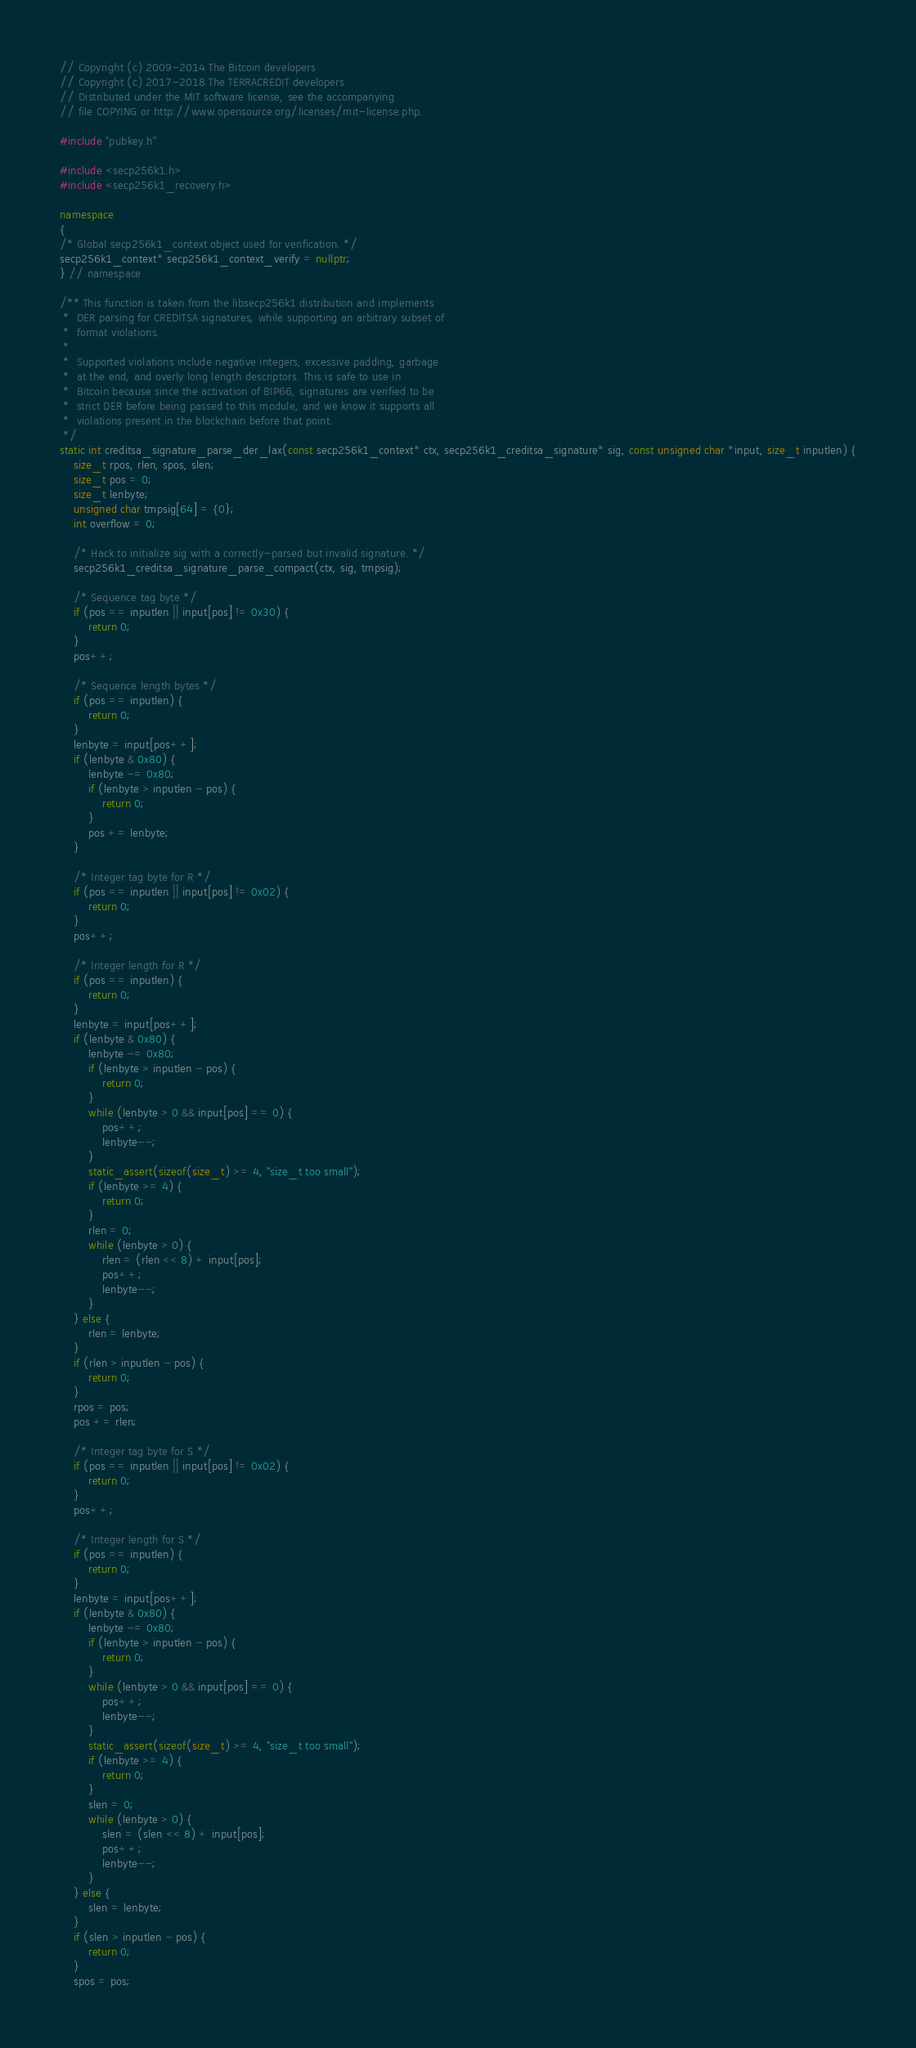<code> <loc_0><loc_0><loc_500><loc_500><_C++_>// Copyright (c) 2009-2014 The Bitcoin developers
// Copyright (c) 2017-2018 The TERRACREDIT developers
// Distributed under the MIT software license, see the accompanying
// file COPYING or http://www.opensource.org/licenses/mit-license.php.

#include "pubkey.h"

#include <secp256k1.h>
#include <secp256k1_recovery.h>

namespace
{
/* Global secp256k1_context object used for verification. */
secp256k1_context* secp256k1_context_verify = nullptr;
} // namespace

/** This function is taken from the libsecp256k1 distribution and implements
 *  DER parsing for CREDITSA signatures, while supporting an arbitrary subset of
 *  format violations.
 *
 *  Supported violations include negative integers, excessive padding, garbage
 *  at the end, and overly long length descriptors. This is safe to use in
 *  Bitcoin because since the activation of BIP66, signatures are verified to be
 *  strict DER before being passed to this module, and we know it supports all
 *  violations present in the blockchain before that point.
 */
static int creditsa_signature_parse_der_lax(const secp256k1_context* ctx, secp256k1_creditsa_signature* sig, const unsigned char *input, size_t inputlen) {
    size_t rpos, rlen, spos, slen;
    size_t pos = 0;
    size_t lenbyte;
    unsigned char tmpsig[64] = {0};
    int overflow = 0;

    /* Hack to initialize sig with a correctly-parsed but invalid signature. */
    secp256k1_creditsa_signature_parse_compact(ctx, sig, tmpsig);

    /* Sequence tag byte */
    if (pos == inputlen || input[pos] != 0x30) {
        return 0;
    }
    pos++;

    /* Sequence length bytes */
    if (pos == inputlen) {
        return 0;
    }
    lenbyte = input[pos++];
    if (lenbyte & 0x80) {
        lenbyte -= 0x80;
        if (lenbyte > inputlen - pos) {
            return 0;
        }
        pos += lenbyte;
    }

    /* Integer tag byte for R */
    if (pos == inputlen || input[pos] != 0x02) {
        return 0;
    }
    pos++;

    /* Integer length for R */
    if (pos == inputlen) {
        return 0;
    }
    lenbyte = input[pos++];
    if (lenbyte & 0x80) {
        lenbyte -= 0x80;
        if (lenbyte > inputlen - pos) {
            return 0;
        }
        while (lenbyte > 0 && input[pos] == 0) {
            pos++;
            lenbyte--;
        }
        static_assert(sizeof(size_t) >= 4, "size_t too small");
        if (lenbyte >= 4) {
            return 0;
        }
        rlen = 0;
        while (lenbyte > 0) {
            rlen = (rlen << 8) + input[pos];
            pos++;
            lenbyte--;
        }
    } else {
        rlen = lenbyte;
    }
    if (rlen > inputlen - pos) {
        return 0;
    }
    rpos = pos;
    pos += rlen;

    /* Integer tag byte for S */
    if (pos == inputlen || input[pos] != 0x02) {
        return 0;
    }
    pos++;

    /* Integer length for S */
    if (pos == inputlen) {
        return 0;
    }
    lenbyte = input[pos++];
    if (lenbyte & 0x80) {
        lenbyte -= 0x80;
        if (lenbyte > inputlen - pos) {
            return 0;
        }
        while (lenbyte > 0 && input[pos] == 0) {
            pos++;
            lenbyte--;
        }
        static_assert(sizeof(size_t) >= 4, "size_t too small");
        if (lenbyte >= 4) {
            return 0;
        }
        slen = 0;
        while (lenbyte > 0) {
            slen = (slen << 8) + input[pos];
            pos++;
            lenbyte--;
        }
    } else {
        slen = lenbyte;
    }
    if (slen > inputlen - pos) {
        return 0;
    }
    spos = pos;
</code> 